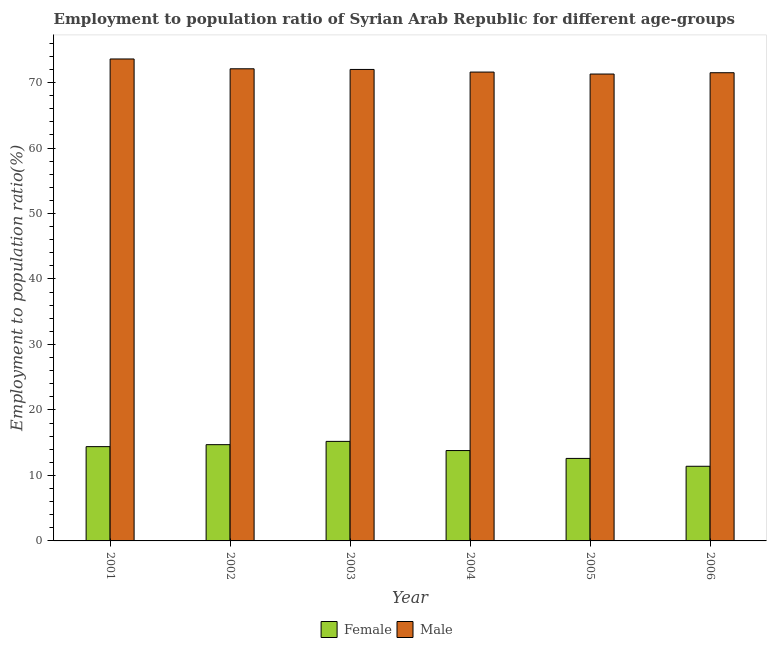Are the number of bars per tick equal to the number of legend labels?
Ensure brevity in your answer.  Yes. How many bars are there on the 4th tick from the left?
Provide a succinct answer. 2. In how many cases, is the number of bars for a given year not equal to the number of legend labels?
Make the answer very short. 0. What is the employment to population ratio(female) in 2003?
Offer a terse response. 15.2. Across all years, what is the maximum employment to population ratio(male)?
Your response must be concise. 73.6. Across all years, what is the minimum employment to population ratio(male)?
Provide a short and direct response. 71.3. What is the total employment to population ratio(male) in the graph?
Your answer should be very brief. 432.1. What is the difference between the employment to population ratio(male) in 2004 and that in 2006?
Provide a succinct answer. 0.1. What is the difference between the employment to population ratio(female) in 2001 and the employment to population ratio(male) in 2006?
Offer a terse response. 3. What is the average employment to population ratio(male) per year?
Your answer should be compact. 72.02. What is the ratio of the employment to population ratio(male) in 2001 to that in 2006?
Provide a short and direct response. 1.03. What is the difference between the highest and the lowest employment to population ratio(female)?
Your answer should be compact. 3.8. What does the 2nd bar from the right in 2005 represents?
Offer a very short reply. Female. How many bars are there?
Your answer should be compact. 12. Are all the bars in the graph horizontal?
Make the answer very short. No. How many years are there in the graph?
Make the answer very short. 6. Does the graph contain any zero values?
Your answer should be very brief. No. Where does the legend appear in the graph?
Provide a succinct answer. Bottom center. What is the title of the graph?
Give a very brief answer. Employment to population ratio of Syrian Arab Republic for different age-groups. What is the label or title of the X-axis?
Keep it short and to the point. Year. What is the Employment to population ratio(%) of Female in 2001?
Offer a very short reply. 14.4. What is the Employment to population ratio(%) of Male in 2001?
Ensure brevity in your answer.  73.6. What is the Employment to population ratio(%) of Female in 2002?
Give a very brief answer. 14.7. What is the Employment to population ratio(%) of Male in 2002?
Your answer should be compact. 72.1. What is the Employment to population ratio(%) of Female in 2003?
Offer a very short reply. 15.2. What is the Employment to population ratio(%) of Male in 2003?
Your answer should be very brief. 72. What is the Employment to population ratio(%) of Female in 2004?
Your answer should be very brief. 13.8. What is the Employment to population ratio(%) of Male in 2004?
Ensure brevity in your answer.  71.6. What is the Employment to population ratio(%) in Female in 2005?
Provide a short and direct response. 12.6. What is the Employment to population ratio(%) of Male in 2005?
Offer a very short reply. 71.3. What is the Employment to population ratio(%) of Female in 2006?
Give a very brief answer. 11.4. What is the Employment to population ratio(%) in Male in 2006?
Make the answer very short. 71.5. Across all years, what is the maximum Employment to population ratio(%) of Female?
Offer a terse response. 15.2. Across all years, what is the maximum Employment to population ratio(%) in Male?
Your response must be concise. 73.6. Across all years, what is the minimum Employment to population ratio(%) of Female?
Your response must be concise. 11.4. Across all years, what is the minimum Employment to population ratio(%) of Male?
Give a very brief answer. 71.3. What is the total Employment to population ratio(%) of Female in the graph?
Your answer should be compact. 82.1. What is the total Employment to population ratio(%) in Male in the graph?
Offer a terse response. 432.1. What is the difference between the Employment to population ratio(%) in Male in 2001 and that in 2002?
Offer a very short reply. 1.5. What is the difference between the Employment to population ratio(%) of Male in 2001 and that in 2003?
Provide a succinct answer. 1.6. What is the difference between the Employment to population ratio(%) of Male in 2001 and that in 2004?
Provide a short and direct response. 2. What is the difference between the Employment to population ratio(%) in Female in 2001 and that in 2005?
Your answer should be very brief. 1.8. What is the difference between the Employment to population ratio(%) in Male in 2001 and that in 2005?
Keep it short and to the point. 2.3. What is the difference between the Employment to population ratio(%) of Female in 2002 and that in 2003?
Ensure brevity in your answer.  -0.5. What is the difference between the Employment to population ratio(%) in Male in 2002 and that in 2003?
Your answer should be compact. 0.1. What is the difference between the Employment to population ratio(%) of Female in 2002 and that in 2004?
Your response must be concise. 0.9. What is the difference between the Employment to population ratio(%) of Male in 2002 and that in 2005?
Your answer should be very brief. 0.8. What is the difference between the Employment to population ratio(%) of Female in 2002 and that in 2006?
Offer a very short reply. 3.3. What is the difference between the Employment to population ratio(%) of Male in 2002 and that in 2006?
Your answer should be very brief. 0.6. What is the difference between the Employment to population ratio(%) in Female in 2003 and that in 2004?
Provide a short and direct response. 1.4. What is the difference between the Employment to population ratio(%) in Male in 2003 and that in 2004?
Your answer should be very brief. 0.4. What is the difference between the Employment to population ratio(%) of Male in 2003 and that in 2005?
Ensure brevity in your answer.  0.7. What is the difference between the Employment to population ratio(%) of Male in 2003 and that in 2006?
Your answer should be very brief. 0.5. What is the difference between the Employment to population ratio(%) in Female in 2004 and that in 2005?
Keep it short and to the point. 1.2. What is the difference between the Employment to population ratio(%) in Female in 2005 and that in 2006?
Provide a succinct answer. 1.2. What is the difference between the Employment to population ratio(%) of Female in 2001 and the Employment to population ratio(%) of Male in 2002?
Your answer should be compact. -57.7. What is the difference between the Employment to population ratio(%) in Female in 2001 and the Employment to population ratio(%) in Male in 2003?
Make the answer very short. -57.6. What is the difference between the Employment to population ratio(%) of Female in 2001 and the Employment to population ratio(%) of Male in 2004?
Your answer should be compact. -57.2. What is the difference between the Employment to population ratio(%) in Female in 2001 and the Employment to population ratio(%) in Male in 2005?
Provide a short and direct response. -56.9. What is the difference between the Employment to population ratio(%) in Female in 2001 and the Employment to population ratio(%) in Male in 2006?
Your answer should be compact. -57.1. What is the difference between the Employment to population ratio(%) of Female in 2002 and the Employment to population ratio(%) of Male in 2003?
Give a very brief answer. -57.3. What is the difference between the Employment to population ratio(%) in Female in 2002 and the Employment to population ratio(%) in Male in 2004?
Offer a terse response. -56.9. What is the difference between the Employment to population ratio(%) of Female in 2002 and the Employment to population ratio(%) of Male in 2005?
Keep it short and to the point. -56.6. What is the difference between the Employment to population ratio(%) in Female in 2002 and the Employment to population ratio(%) in Male in 2006?
Offer a terse response. -56.8. What is the difference between the Employment to population ratio(%) of Female in 2003 and the Employment to population ratio(%) of Male in 2004?
Make the answer very short. -56.4. What is the difference between the Employment to population ratio(%) in Female in 2003 and the Employment to population ratio(%) in Male in 2005?
Your answer should be very brief. -56.1. What is the difference between the Employment to population ratio(%) of Female in 2003 and the Employment to population ratio(%) of Male in 2006?
Offer a terse response. -56.3. What is the difference between the Employment to population ratio(%) in Female in 2004 and the Employment to population ratio(%) in Male in 2005?
Ensure brevity in your answer.  -57.5. What is the difference between the Employment to population ratio(%) of Female in 2004 and the Employment to population ratio(%) of Male in 2006?
Give a very brief answer. -57.7. What is the difference between the Employment to population ratio(%) in Female in 2005 and the Employment to population ratio(%) in Male in 2006?
Give a very brief answer. -58.9. What is the average Employment to population ratio(%) in Female per year?
Provide a succinct answer. 13.68. What is the average Employment to population ratio(%) in Male per year?
Offer a terse response. 72.02. In the year 2001, what is the difference between the Employment to population ratio(%) in Female and Employment to population ratio(%) in Male?
Your answer should be very brief. -59.2. In the year 2002, what is the difference between the Employment to population ratio(%) of Female and Employment to population ratio(%) of Male?
Make the answer very short. -57.4. In the year 2003, what is the difference between the Employment to population ratio(%) in Female and Employment to population ratio(%) in Male?
Provide a succinct answer. -56.8. In the year 2004, what is the difference between the Employment to population ratio(%) in Female and Employment to population ratio(%) in Male?
Provide a succinct answer. -57.8. In the year 2005, what is the difference between the Employment to population ratio(%) of Female and Employment to population ratio(%) of Male?
Keep it short and to the point. -58.7. In the year 2006, what is the difference between the Employment to population ratio(%) in Female and Employment to population ratio(%) in Male?
Your answer should be very brief. -60.1. What is the ratio of the Employment to population ratio(%) of Female in 2001 to that in 2002?
Offer a terse response. 0.98. What is the ratio of the Employment to population ratio(%) in Male in 2001 to that in 2002?
Your answer should be compact. 1.02. What is the ratio of the Employment to population ratio(%) of Male in 2001 to that in 2003?
Offer a very short reply. 1.02. What is the ratio of the Employment to population ratio(%) in Female in 2001 to that in 2004?
Your response must be concise. 1.04. What is the ratio of the Employment to population ratio(%) in Male in 2001 to that in 2004?
Your answer should be compact. 1.03. What is the ratio of the Employment to population ratio(%) in Female in 2001 to that in 2005?
Give a very brief answer. 1.14. What is the ratio of the Employment to population ratio(%) in Male in 2001 to that in 2005?
Offer a very short reply. 1.03. What is the ratio of the Employment to population ratio(%) of Female in 2001 to that in 2006?
Provide a short and direct response. 1.26. What is the ratio of the Employment to population ratio(%) in Male in 2001 to that in 2006?
Provide a succinct answer. 1.03. What is the ratio of the Employment to population ratio(%) of Female in 2002 to that in 2003?
Your answer should be very brief. 0.97. What is the ratio of the Employment to population ratio(%) in Male in 2002 to that in 2003?
Give a very brief answer. 1. What is the ratio of the Employment to population ratio(%) in Female in 2002 to that in 2004?
Offer a very short reply. 1.07. What is the ratio of the Employment to population ratio(%) of Male in 2002 to that in 2004?
Offer a very short reply. 1.01. What is the ratio of the Employment to population ratio(%) of Female in 2002 to that in 2005?
Make the answer very short. 1.17. What is the ratio of the Employment to population ratio(%) of Male in 2002 to that in 2005?
Make the answer very short. 1.01. What is the ratio of the Employment to population ratio(%) in Female in 2002 to that in 2006?
Your answer should be compact. 1.29. What is the ratio of the Employment to population ratio(%) of Male in 2002 to that in 2006?
Offer a very short reply. 1.01. What is the ratio of the Employment to population ratio(%) of Female in 2003 to that in 2004?
Make the answer very short. 1.1. What is the ratio of the Employment to population ratio(%) of Male in 2003 to that in 2004?
Give a very brief answer. 1.01. What is the ratio of the Employment to population ratio(%) of Female in 2003 to that in 2005?
Your response must be concise. 1.21. What is the ratio of the Employment to population ratio(%) in Male in 2003 to that in 2005?
Your answer should be compact. 1.01. What is the ratio of the Employment to population ratio(%) of Female in 2003 to that in 2006?
Offer a very short reply. 1.33. What is the ratio of the Employment to population ratio(%) of Male in 2003 to that in 2006?
Your answer should be very brief. 1.01. What is the ratio of the Employment to population ratio(%) of Female in 2004 to that in 2005?
Make the answer very short. 1.1. What is the ratio of the Employment to population ratio(%) of Female in 2004 to that in 2006?
Give a very brief answer. 1.21. What is the ratio of the Employment to population ratio(%) of Male in 2004 to that in 2006?
Your answer should be very brief. 1. What is the ratio of the Employment to population ratio(%) in Female in 2005 to that in 2006?
Make the answer very short. 1.11. What is the ratio of the Employment to population ratio(%) of Male in 2005 to that in 2006?
Make the answer very short. 1. What is the difference between the highest and the second highest Employment to population ratio(%) of Male?
Give a very brief answer. 1.5. What is the difference between the highest and the lowest Employment to population ratio(%) in Male?
Provide a succinct answer. 2.3. 